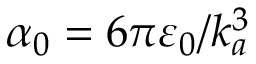<formula> <loc_0><loc_0><loc_500><loc_500>\alpha _ { 0 } = 6 \pi \varepsilon _ { 0 } / k _ { a } ^ { 3 }</formula> 